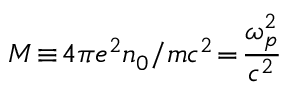<formula> <loc_0><loc_0><loc_500><loc_500>M \, \equiv \, 4 \pi e ^ { 2 } n _ { 0 } / m c ^ { 2 } \, = \, \frac { \omega _ { p } ^ { 2 } } { c ^ { 2 } }</formula> 